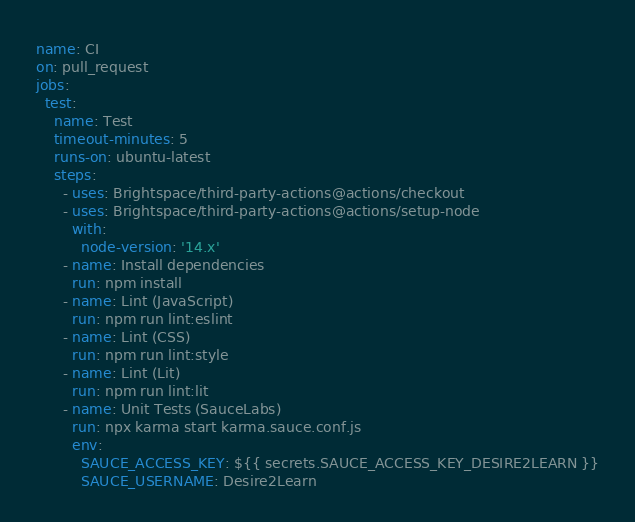<code> <loc_0><loc_0><loc_500><loc_500><_YAML_>name: CI
on: pull_request
jobs:
  test:
    name: Test
    timeout-minutes: 5
    runs-on: ubuntu-latest
    steps:
      - uses: Brightspace/third-party-actions@actions/checkout
      - uses: Brightspace/third-party-actions@actions/setup-node
        with:
          node-version: '14.x'
      - name: Install dependencies
        run: npm install
      - name: Lint (JavaScript)
        run: npm run lint:eslint
      - name: Lint (CSS)
        run: npm run lint:style
      - name: Lint (Lit)
        run: npm run lint:lit
      - name: Unit Tests (SauceLabs)
        run: npx karma start karma.sauce.conf.js
        env:
          SAUCE_ACCESS_KEY: ${{ secrets.SAUCE_ACCESS_KEY_DESIRE2LEARN }}
          SAUCE_USERNAME: Desire2Learn
</code> 